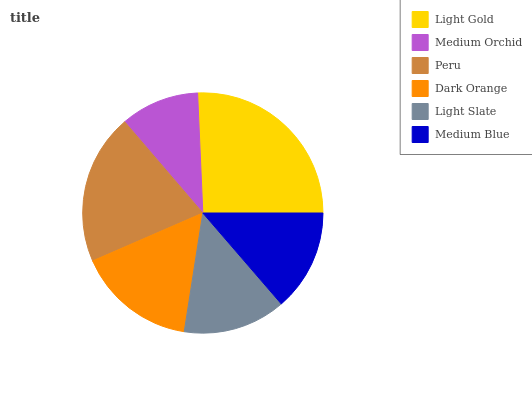Is Medium Orchid the minimum?
Answer yes or no. Yes. Is Light Gold the maximum?
Answer yes or no. Yes. Is Peru the minimum?
Answer yes or no. No. Is Peru the maximum?
Answer yes or no. No. Is Peru greater than Medium Orchid?
Answer yes or no. Yes. Is Medium Orchid less than Peru?
Answer yes or no. Yes. Is Medium Orchid greater than Peru?
Answer yes or no. No. Is Peru less than Medium Orchid?
Answer yes or no. No. Is Dark Orange the high median?
Answer yes or no. Yes. Is Light Slate the low median?
Answer yes or no. Yes. Is Light Slate the high median?
Answer yes or no. No. Is Light Gold the low median?
Answer yes or no. No. 